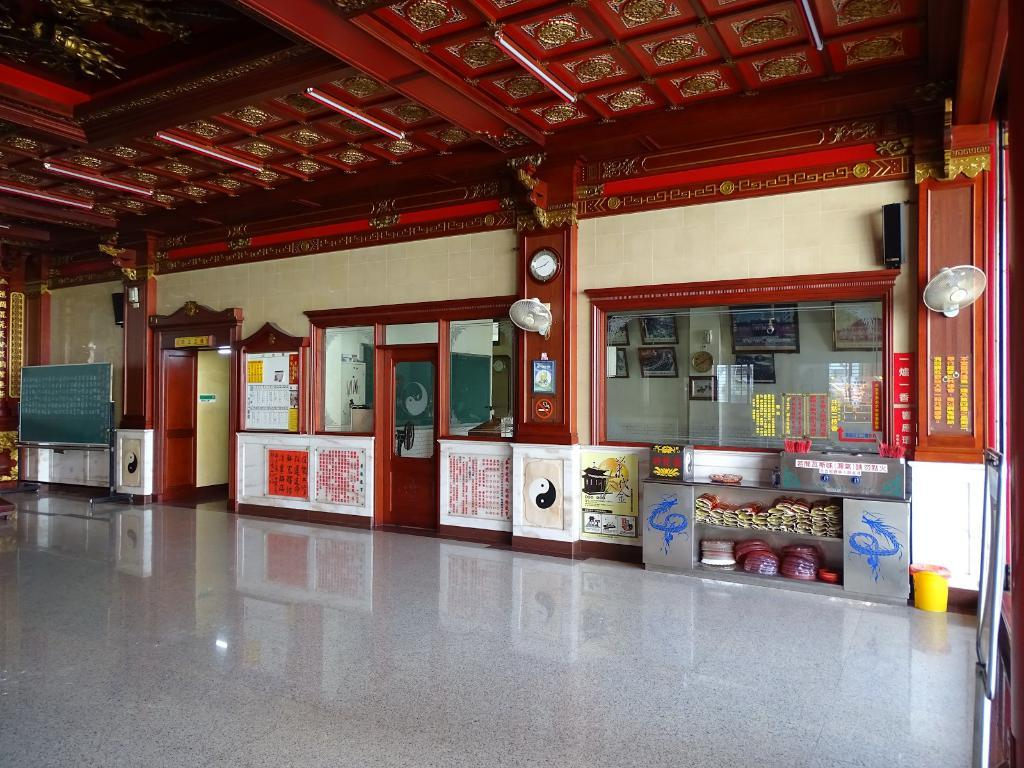<image>
Summarize the visual content of the image. The interior of a clean building with signs in Chinese all around. 